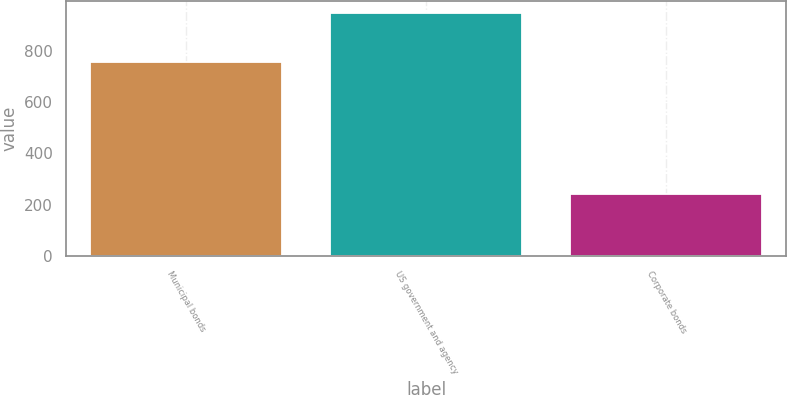<chart> <loc_0><loc_0><loc_500><loc_500><bar_chart><fcel>Municipal bonds<fcel>US government and agency<fcel>Corporate bonds<nl><fcel>756<fcel>947<fcel>241<nl></chart> 